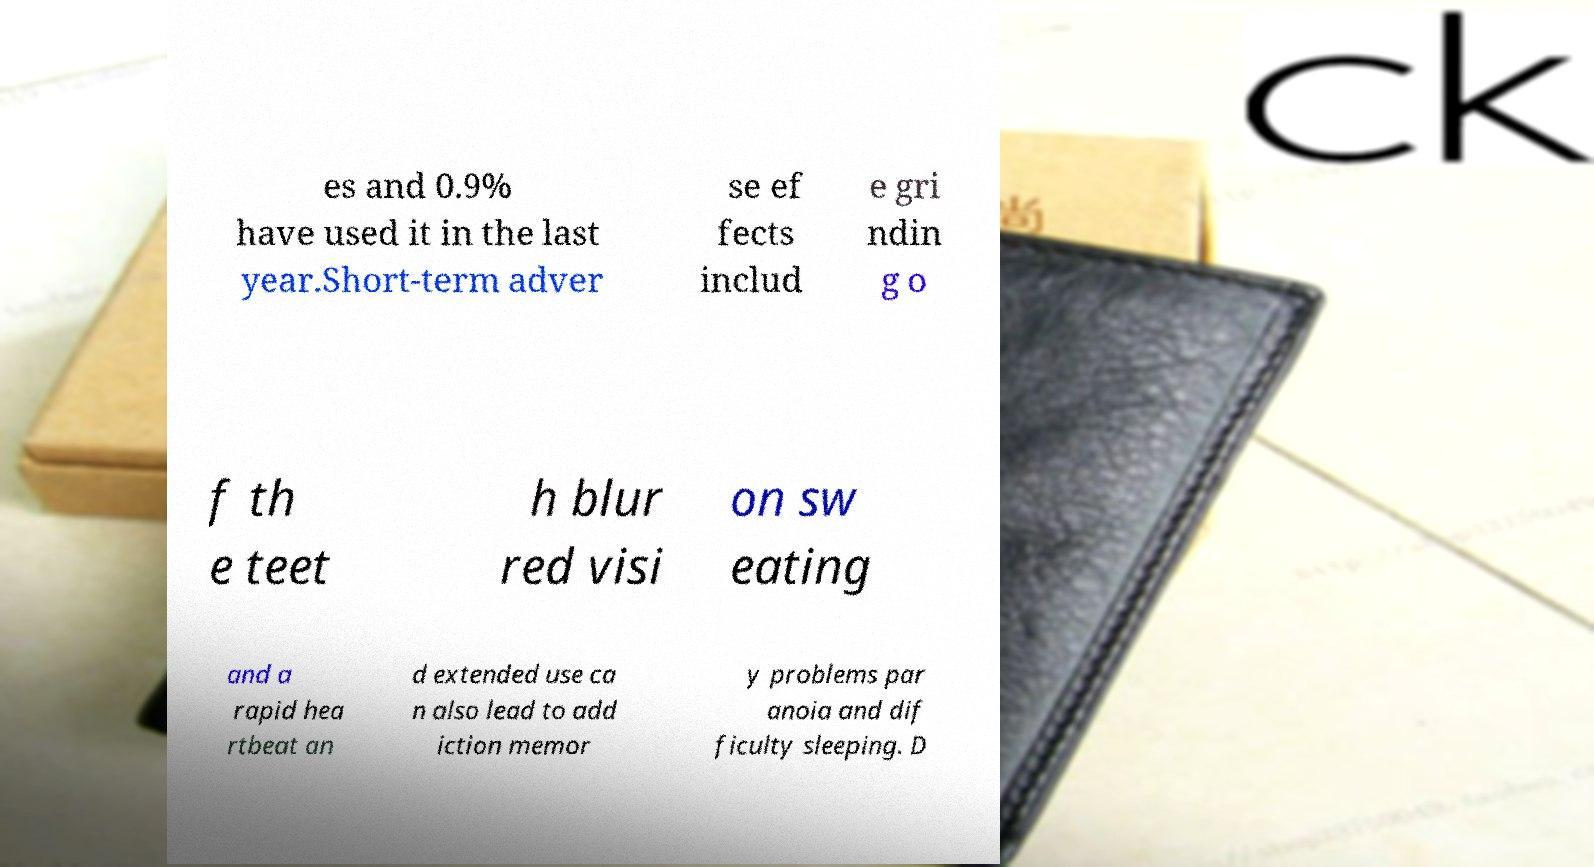I need the written content from this picture converted into text. Can you do that? es and 0.9% have used it in the last year.Short-term adver se ef fects includ e gri ndin g o f th e teet h blur red visi on sw eating and a rapid hea rtbeat an d extended use ca n also lead to add iction memor y problems par anoia and dif ficulty sleeping. D 